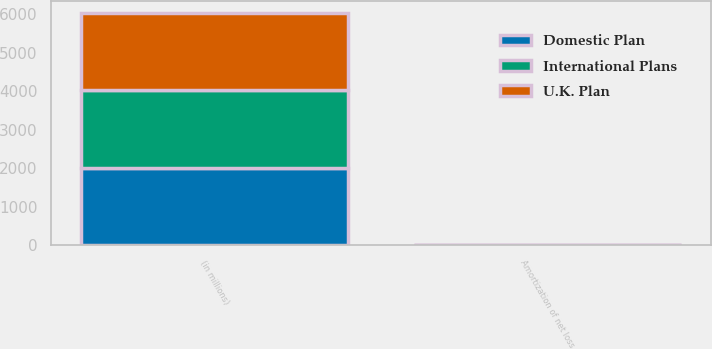Convert chart to OTSL. <chart><loc_0><loc_0><loc_500><loc_500><stacked_bar_chart><ecel><fcel>(in millions)<fcel>Amortization of net loss<nl><fcel>U.K. Plan<fcel>2013<fcel>3<nl><fcel>Domestic Plan<fcel>2013<fcel>4<nl><fcel>International Plans<fcel>2013<fcel>2<nl></chart> 